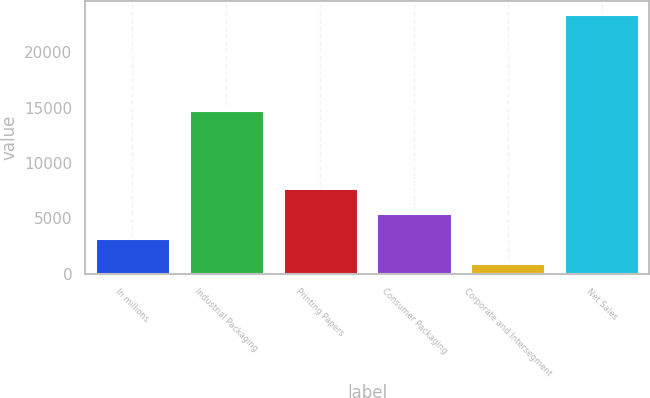<chart> <loc_0><loc_0><loc_500><loc_500><bar_chart><fcel>In millions<fcel>Industrial Packaging<fcel>Printing Papers<fcel>Consumer Packaging<fcel>Corporate and Intersegment<fcel>Net Sales<nl><fcel>3218.6<fcel>14810<fcel>7721.8<fcel>5470.2<fcel>967<fcel>23483<nl></chart> 